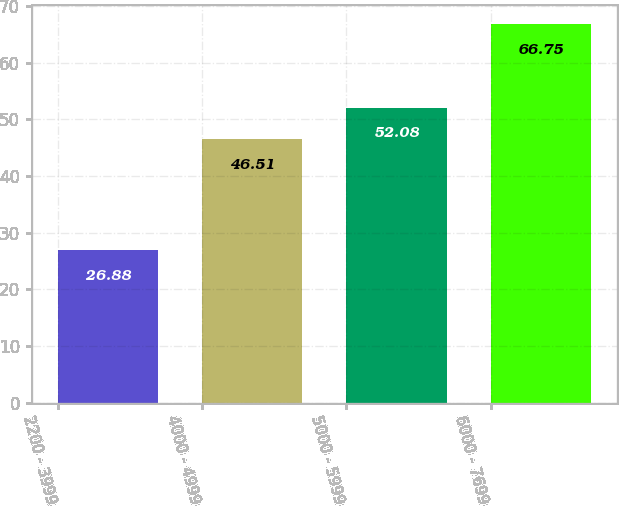<chart> <loc_0><loc_0><loc_500><loc_500><bar_chart><fcel>2200 - 3999<fcel>4000 - 4999<fcel>5000 - 5999<fcel>6000 - 7699<nl><fcel>26.88<fcel>46.51<fcel>52.08<fcel>66.75<nl></chart> 